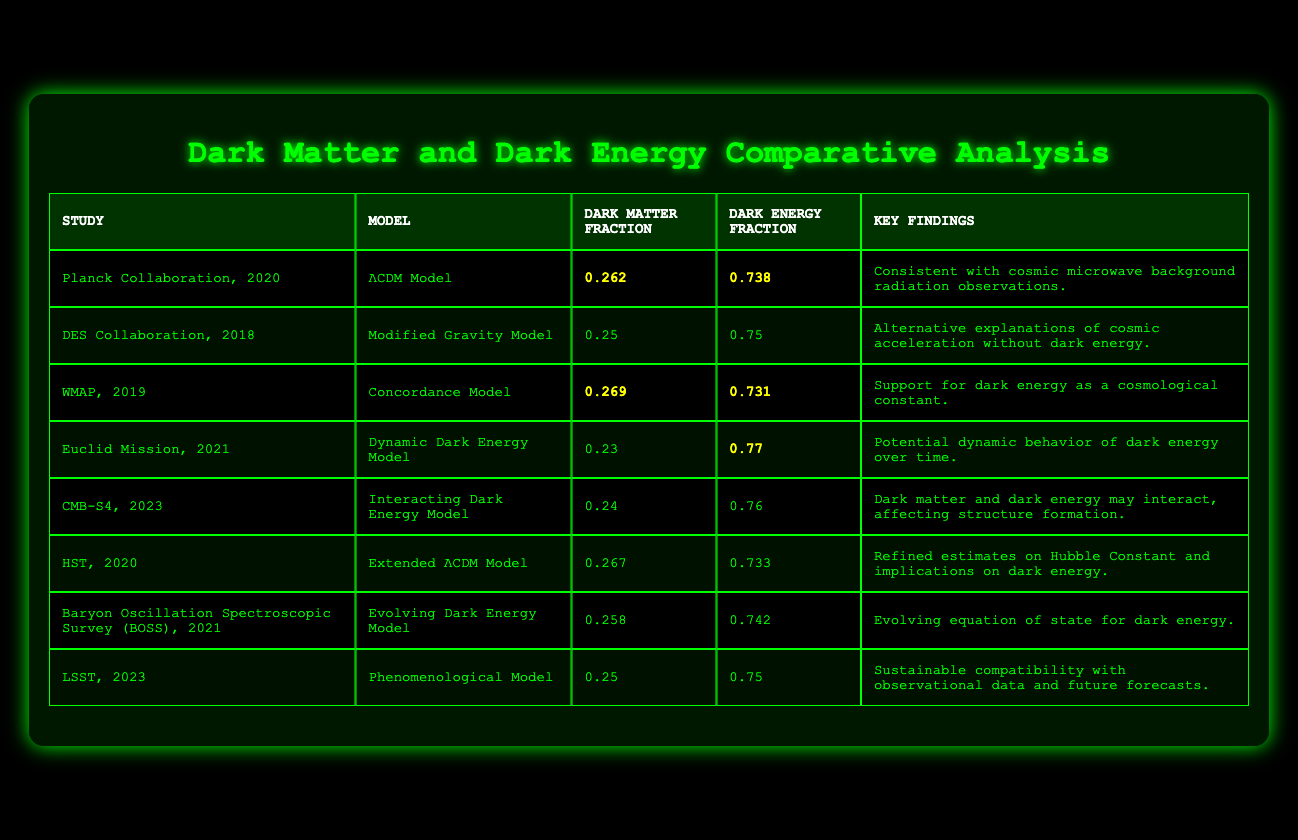What is the dark matter fraction according to the WMAP study? The WMAP study indicates a dark matter fraction of 0.269, which can be directly retrieved from the table.
Answer: 0.269 Which study reports the highest dark energy fraction? The Euclid Mission study reports the highest dark energy fraction of 0.77, as seen in the table under dark energy fraction.
Answer: 0.77 What are the key findings of the CMB-S4 study? The CMB-S4 study's key findings state that dark matter and dark energy may interact, affecting structure formation. This information is available directly in the table.
Answer: Dark matter and dark energy may interact, affecting structure formation Which models have a dark matter fraction below 0.25? Only the Euclid Mission model, with a dark matter fraction of 0.23, falls below 0.25 according to the table.
Answer: Dynamic Dark Energy Model What is the average dark energy fraction across all studies? To find the average dark energy fraction, we sum the fractions (0.738 + 0.75 + 0.731 + 0.77 + 0.76 + 0.733 + 0.742 + 0.75) = 5.558. There are 8 studies, so the average is 5.558 / 8 = 0.69475, which rounds to approximately 0.695.
Answer: 0.695 Is there a model that suggests an alternative explanation without dark energy? Yes, the DES Collaboration's Modified Gravity Model suggests alternative explanations of cosmic acceleration without dark energy, as noted in the key findings of that row.
Answer: Yes Which study has a dark matter fraction closest to 0.25? The studies from DES Collaboration and LSST both have a dark matter fraction of 0.25, making them equally the closest to 0.25.
Answer: DES Collaboration, LSST What is the combined dark matter and dark energy fraction for the Extended ΛCDM Model? The combined fraction is calculated as 0.267 (dark matter fraction) + 0.733 (dark energy fraction) = 1. All models should sum to 1 as they represent total energy content in the universe.
Answer: 1 Does the HST study suggest any implications for dark energy? Yes, the HST study mentions refined estimates on the Hubble Constant and implications on dark energy, confirming that the table accurately reflects this finding.
Answer: Yes Which model indicates a potential dynamic behavior of dark energy over time? The Euclid Mission's Dynamic Dark Energy Model indicates a potential dynamic behavior of dark energy over time, as highlighted in the findings listed.
Answer: Dynamic Dark Energy Model What is the difference between the highest and lowest dark matter fractions in the studies? The highest dark matter fraction is 0.269 (WMAP study) and the lowest is 0.23 (Euclid Mission), so the difference is calculated as 0.269 - 0.23 = 0.039.
Answer: 0.039 